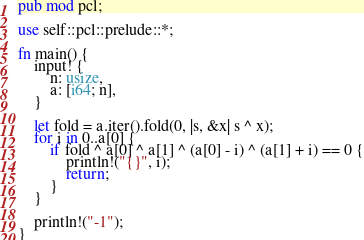Convert code to text. <code><loc_0><loc_0><loc_500><loc_500><_Rust_>pub mod pcl;

use self::pcl::prelude::*;

fn main() {
    input! {
        n: usize,
        a: [i64; n],
    }

    let fold = a.iter().fold(0, |s, &x| s ^ x);
    for i in 0..a[0] {
        if fold ^ a[0] ^ a[1] ^ (a[0] - i) ^ (a[1] + i) == 0 {
            println!("{}", i);
            return;
        }
    }

    println!("-1");
}
</code> 